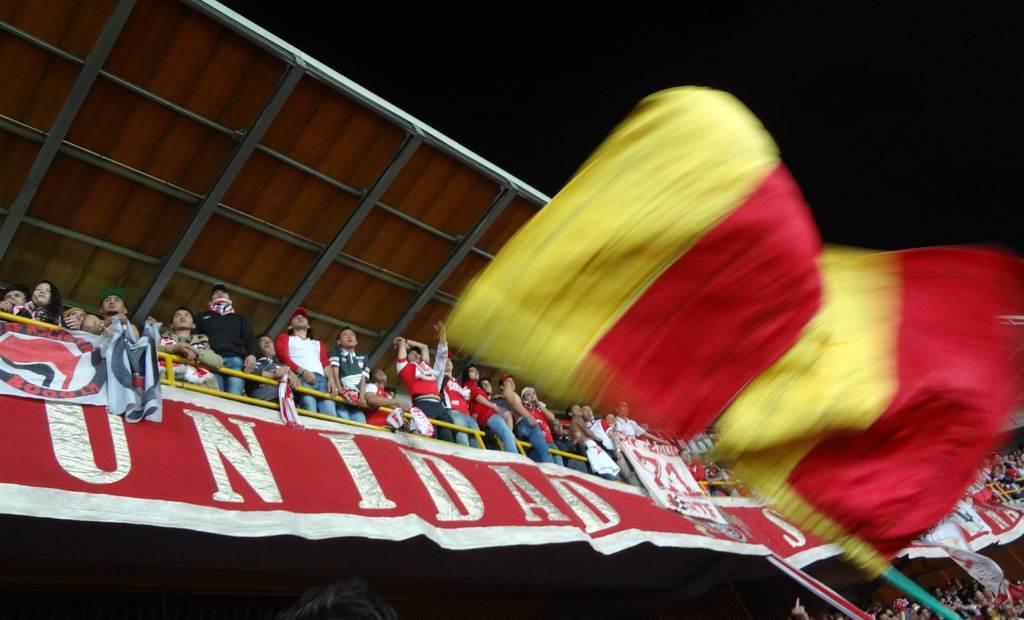In one or two sentences, can you explain what this image depicts? In the center of the image we can see one flag, which is in yellow and red color. In the background there is a roof, fence, banners, group of people are standing, few people are holding some objects and a few other objects. 